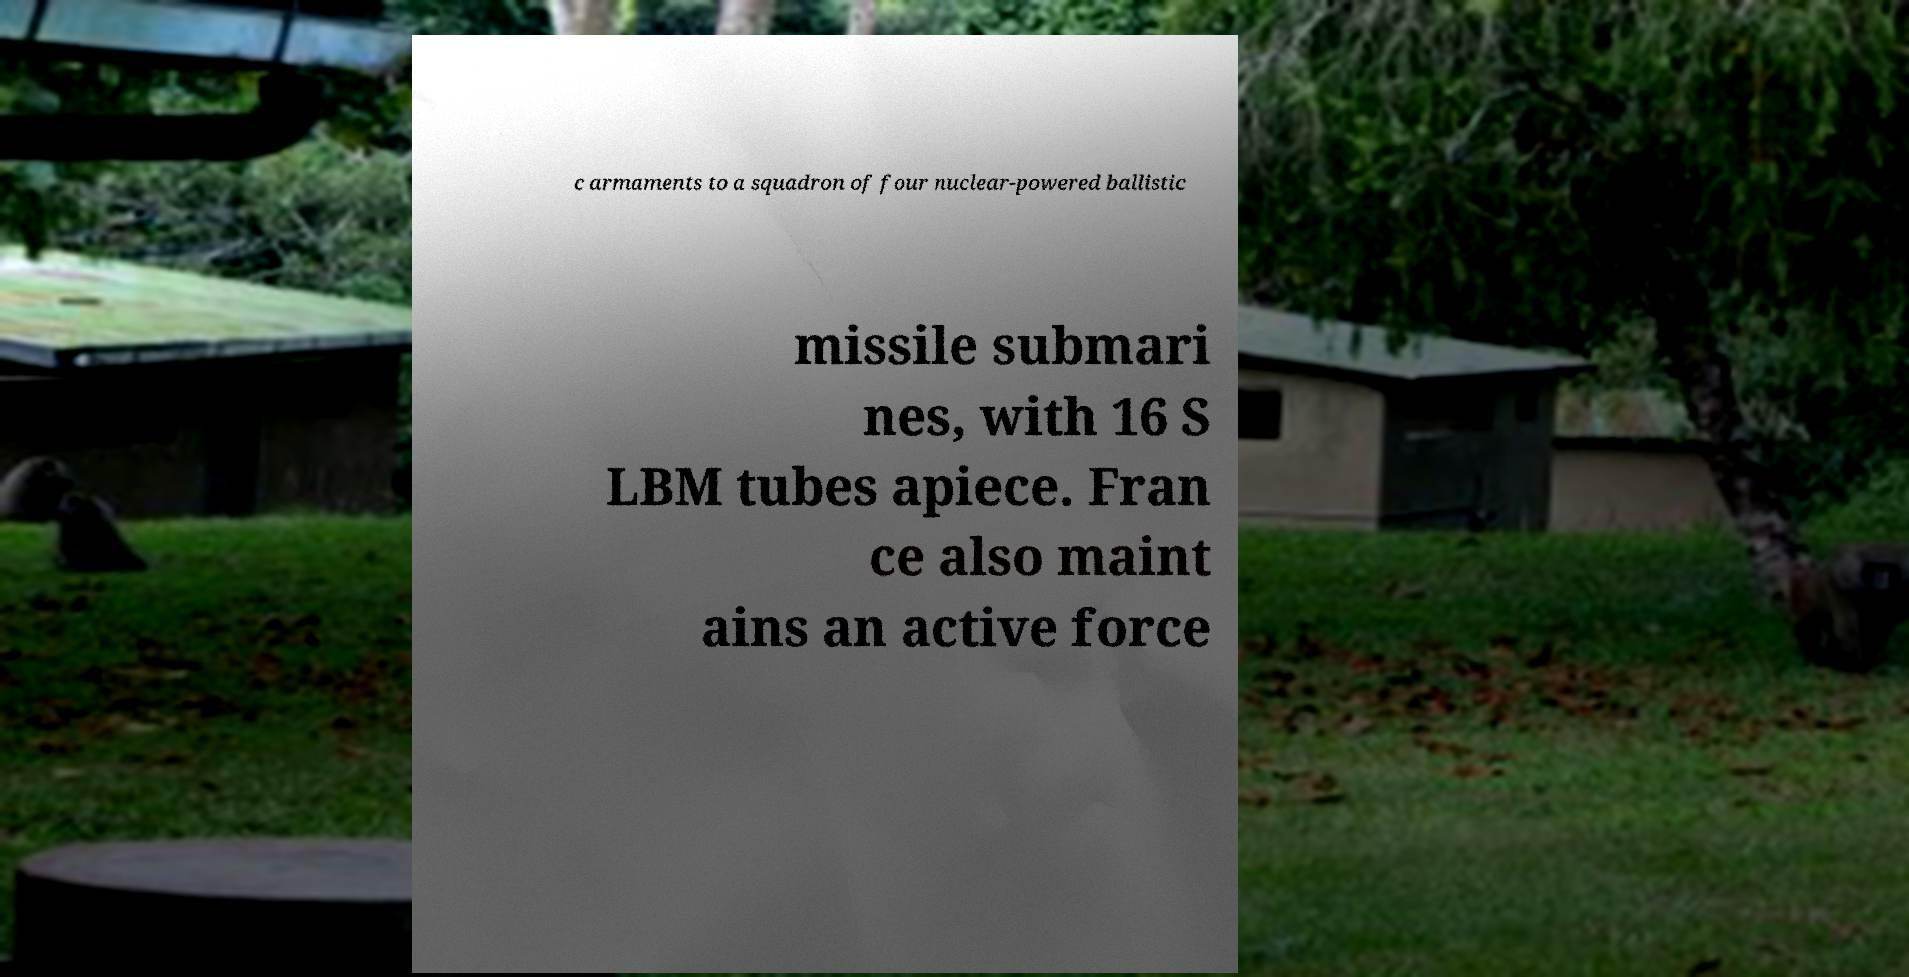For documentation purposes, I need the text within this image transcribed. Could you provide that? c armaments to a squadron of four nuclear-powered ballistic missile submari nes, with 16 S LBM tubes apiece. Fran ce also maint ains an active force 